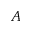<formula> <loc_0><loc_0><loc_500><loc_500>A</formula> 